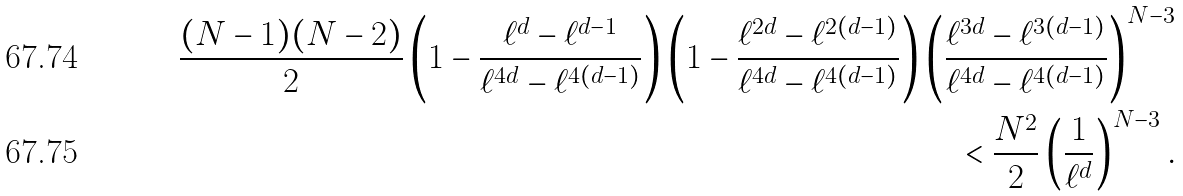<formula> <loc_0><loc_0><loc_500><loc_500>\frac { ( N - 1 ) ( N - 2 ) } { 2 } \left ( 1 - \frac { \ell ^ { d } - \ell ^ { d - 1 } } { \ell ^ { 4 d } - \ell ^ { 4 ( d - 1 ) } } \right ) \left ( 1 - \frac { \ell ^ { 2 d } - \ell ^ { 2 ( d - 1 ) } } { \ell ^ { 4 d } - \ell ^ { 4 ( d - 1 ) } } \right ) \left ( \frac { \ell ^ { 3 d } - \ell ^ { 3 ( d - 1 ) } } { \ell ^ { 4 d } - \ell ^ { 4 ( d - 1 ) } } \right ) ^ { N - 3 } \\ < \frac { N ^ { 2 } } { 2 } \left ( \frac { 1 } { \ell ^ { d } } \right ) ^ { N - 3 } .</formula> 